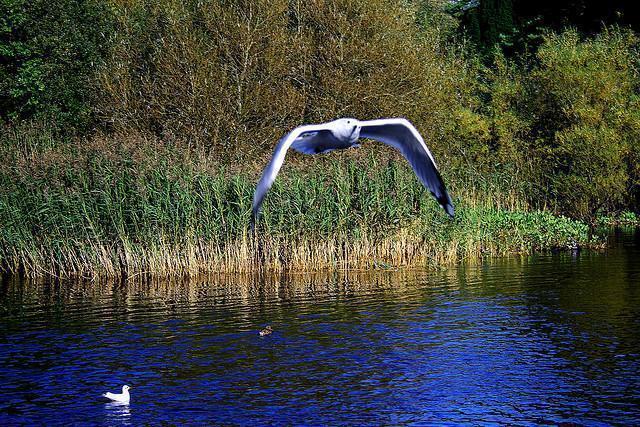The bird on the water has what type feet?
Make your selection from the four choices given to correctly answer the question.
Options: Club, taloned, none, webbed. Webbed. 